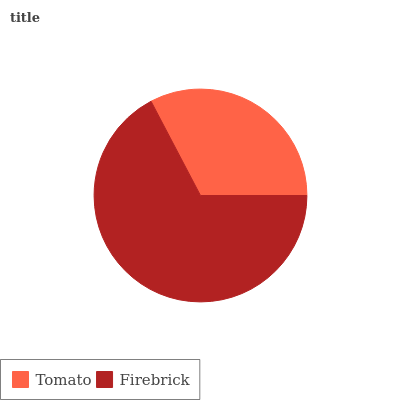Is Tomato the minimum?
Answer yes or no. Yes. Is Firebrick the maximum?
Answer yes or no. Yes. Is Firebrick the minimum?
Answer yes or no. No. Is Firebrick greater than Tomato?
Answer yes or no. Yes. Is Tomato less than Firebrick?
Answer yes or no. Yes. Is Tomato greater than Firebrick?
Answer yes or no. No. Is Firebrick less than Tomato?
Answer yes or no. No. Is Firebrick the high median?
Answer yes or no. Yes. Is Tomato the low median?
Answer yes or no. Yes. Is Tomato the high median?
Answer yes or no. No. Is Firebrick the low median?
Answer yes or no. No. 